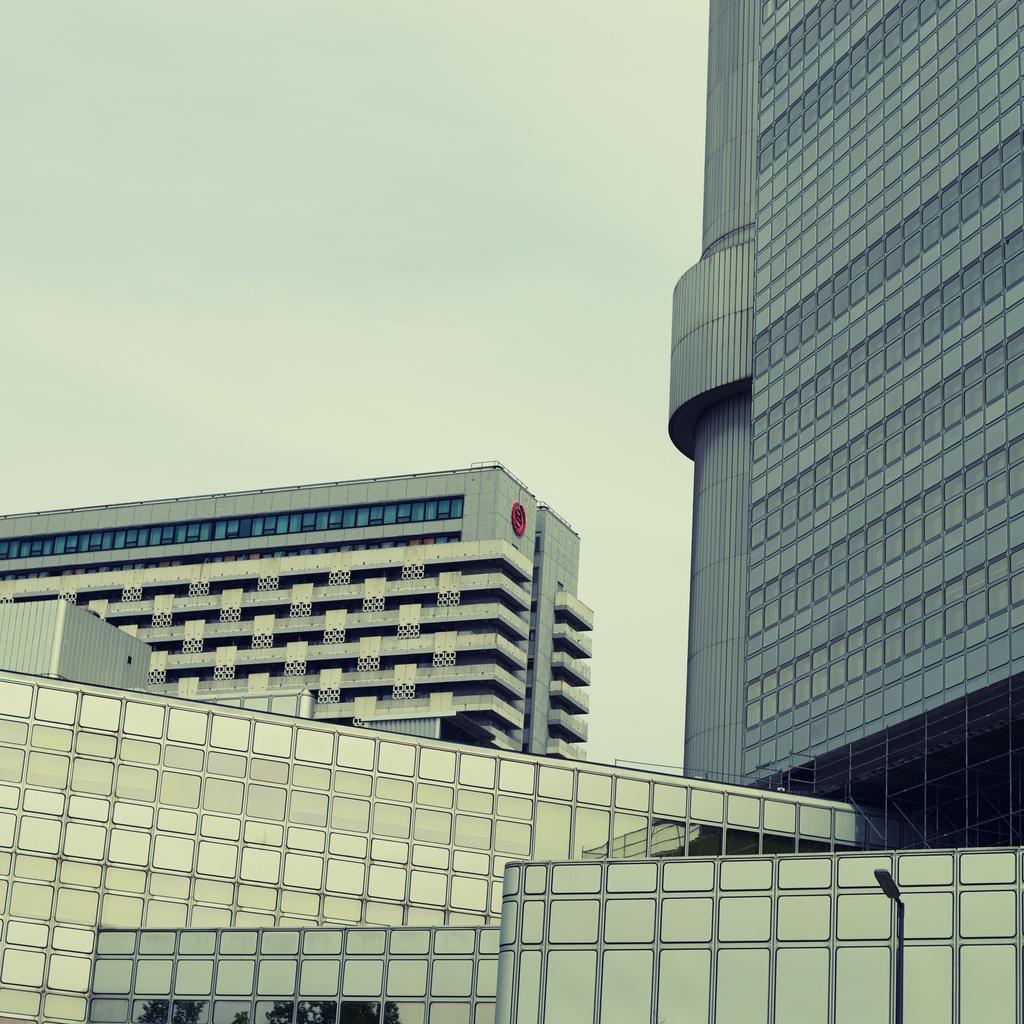In one or two sentences, can you explain what this image depicts? In this picture I can see buildings, a pole light and a cloudy sky 